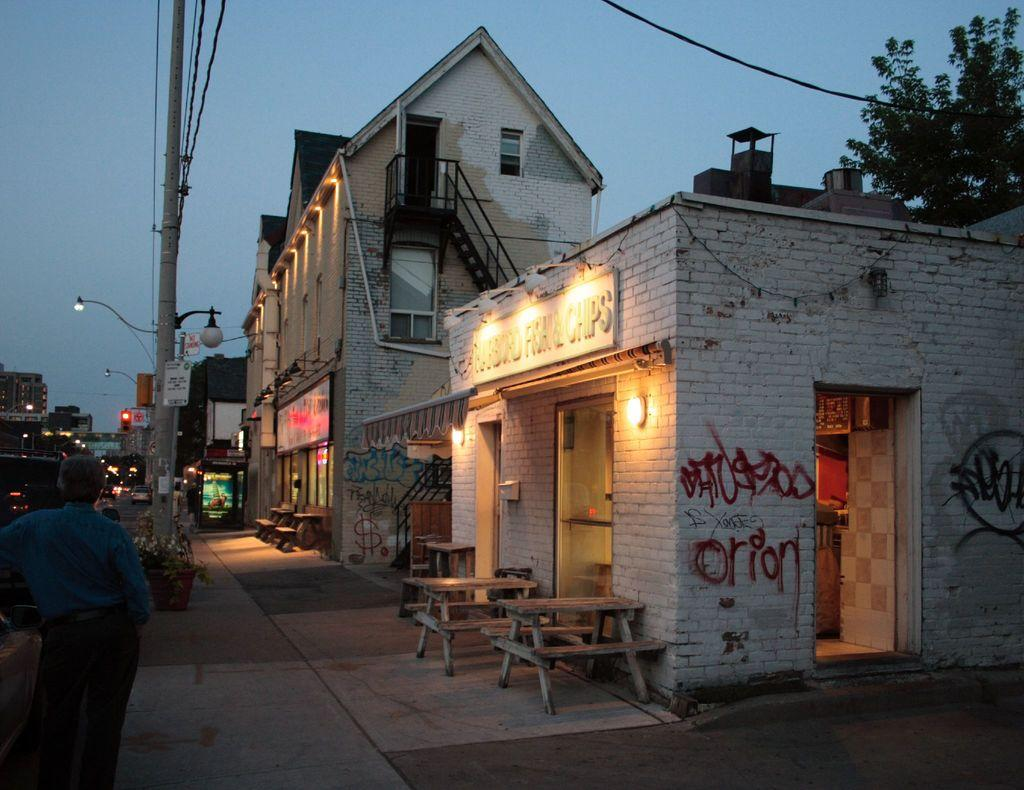What is the main subject in the image? There is a person standing in the image. What type of furniture is present in the image? There is a bench and a table in the image. What type of structures can be seen in the image? There are buildings in the image. What part of the natural environment is visible in the image? The sky, a tree, and a plant are visible in the image. What man-made objects can be seen in the image? There is a pole and a light in the image. What type of drum is being played by the person in the image? There is no drum present in the image; the person is simply standing. 